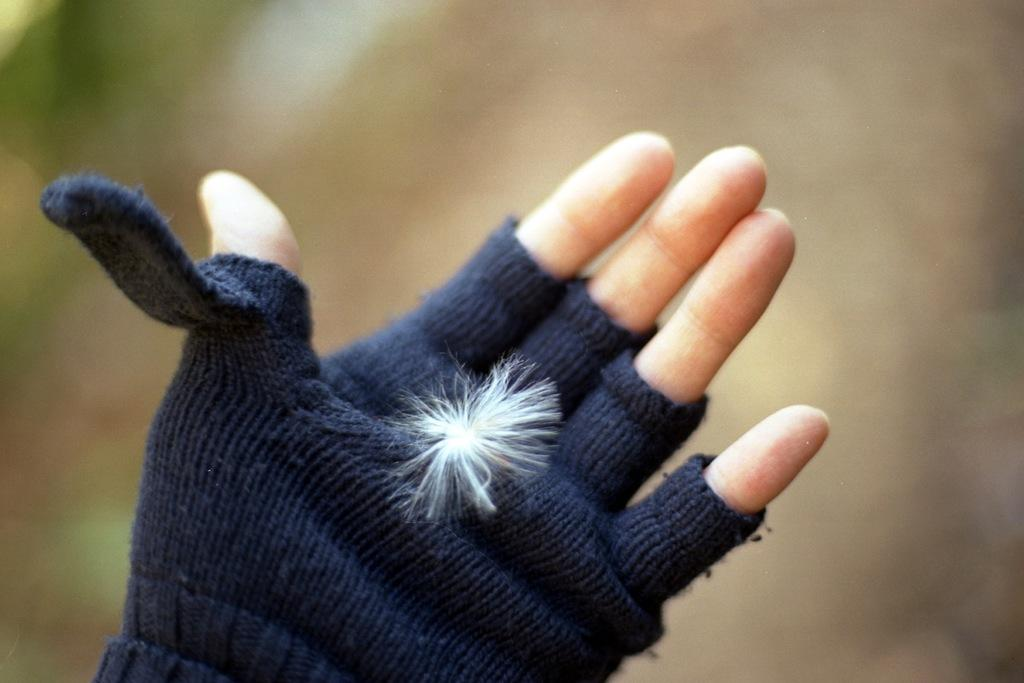What can be seen on the hand in the image? The hand is wearing gloves, and there is a white object on the hand. What might the white object be? It is not clear from the image what the white object is, but it could be a ball, a piece of paper, or another small object. How would you describe the background of the image? The background of the image is blurred. What type of insect can be seen crawling on the spot in the image? There is no spot or insect present in the image. 